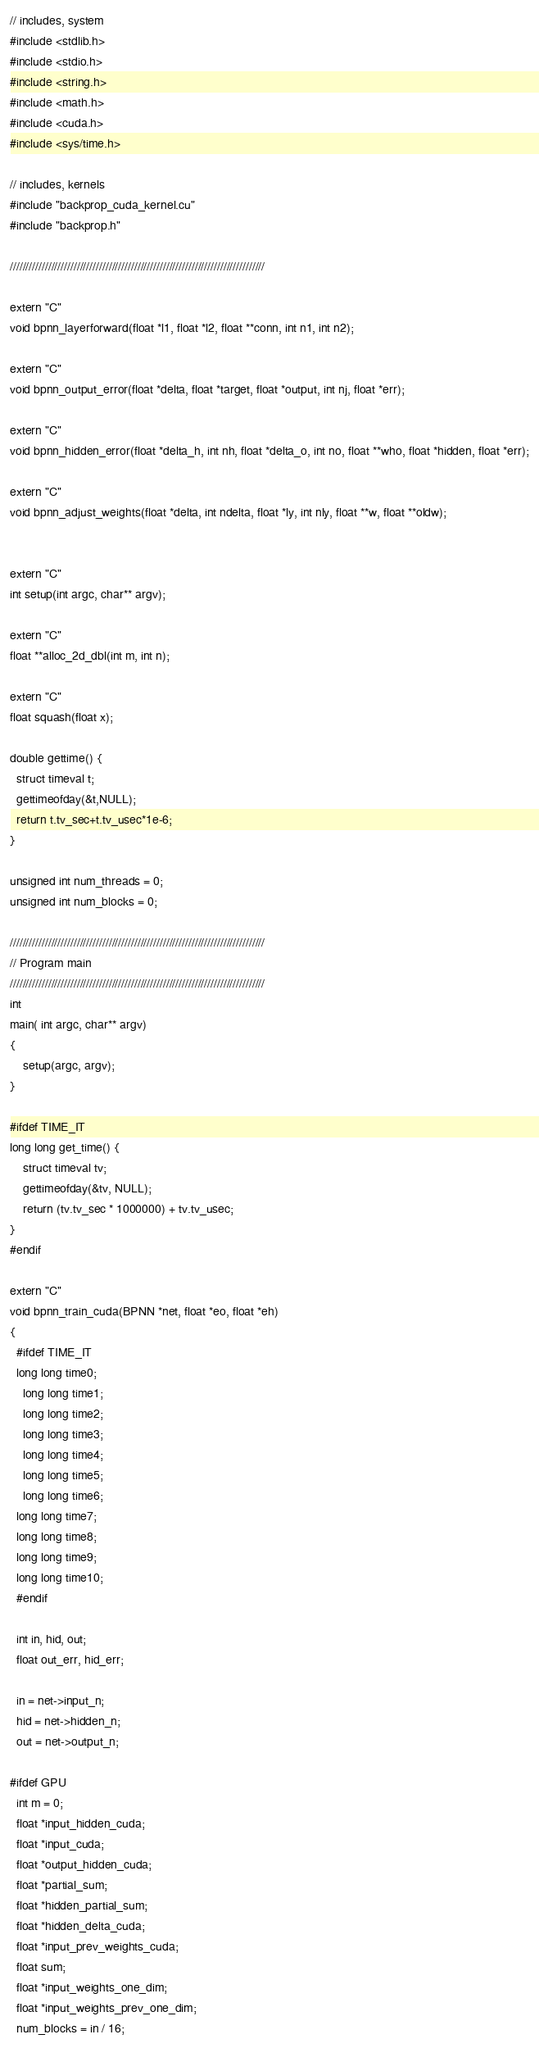Convert code to text. <code><loc_0><loc_0><loc_500><loc_500><_Cuda_>

// includes, system
#include <stdlib.h>
#include <stdio.h>
#include <string.h>
#include <math.h>
#include <cuda.h>
#include <sys/time.h>

// includes, kernels
#include "backprop_cuda_kernel.cu"
#include "backprop.h"

////////////////////////////////////////////////////////////////////////////////

extern "C"
void bpnn_layerforward(float *l1, float *l2, float **conn, int n1, int n2);

extern "C"
void bpnn_output_error(float *delta, float *target, float *output, int nj, float *err);

extern "C"
void bpnn_hidden_error(float *delta_h, int nh, float *delta_o, int no, float **who, float *hidden, float *err);

extern "C" 
void bpnn_adjust_weights(float *delta, int ndelta, float *ly, int nly, float **w, float **oldw);


extern "C"
int setup(int argc, char** argv);

extern "C"
float **alloc_2d_dbl(int m, int n);

extern "C"
float squash(float x);

double gettime() {
  struct timeval t;
  gettimeofday(&t,NULL);
  return t.tv_sec+t.tv_usec*1e-6;
}

unsigned int num_threads = 0;
unsigned int num_blocks = 0;

////////////////////////////////////////////////////////////////////////////////
// Program main
////////////////////////////////////////////////////////////////////////////////
int
main( int argc, char** argv) 
{
	setup(argc, argv);
}

#ifdef TIME_IT
long long get_time() {
	struct timeval tv;
	gettimeofday(&tv, NULL);
	return (tv.tv_sec * 1000000) + tv.tv_usec;
}
#endif

extern "C"
void bpnn_train_cuda(BPNN *net, float *eo, float *eh)
{
  #ifdef TIME_IT
  long long time0;
	long long time1;
	long long time2;
	long long time3;
	long long time4;
	long long time5;
	long long time6;
  long long time7;
  long long time8;
  long long time9;
  long long time10;
  #endif

  int in, hid, out;
  float out_err, hid_err;
  
  in = net->input_n;
  hid = net->hidden_n;
  out = net->output_n;   
   
#ifdef GPU  
  int m = 0;
  float *input_hidden_cuda;
  float *input_cuda;
  float *output_hidden_cuda;
  float *partial_sum;
  float *hidden_partial_sum;
  float *hidden_delta_cuda;
  float *input_prev_weights_cuda;
  float sum;
  float *input_weights_one_dim;
  float *input_weights_prev_one_dim;
  num_blocks = in / 16;  </code> 